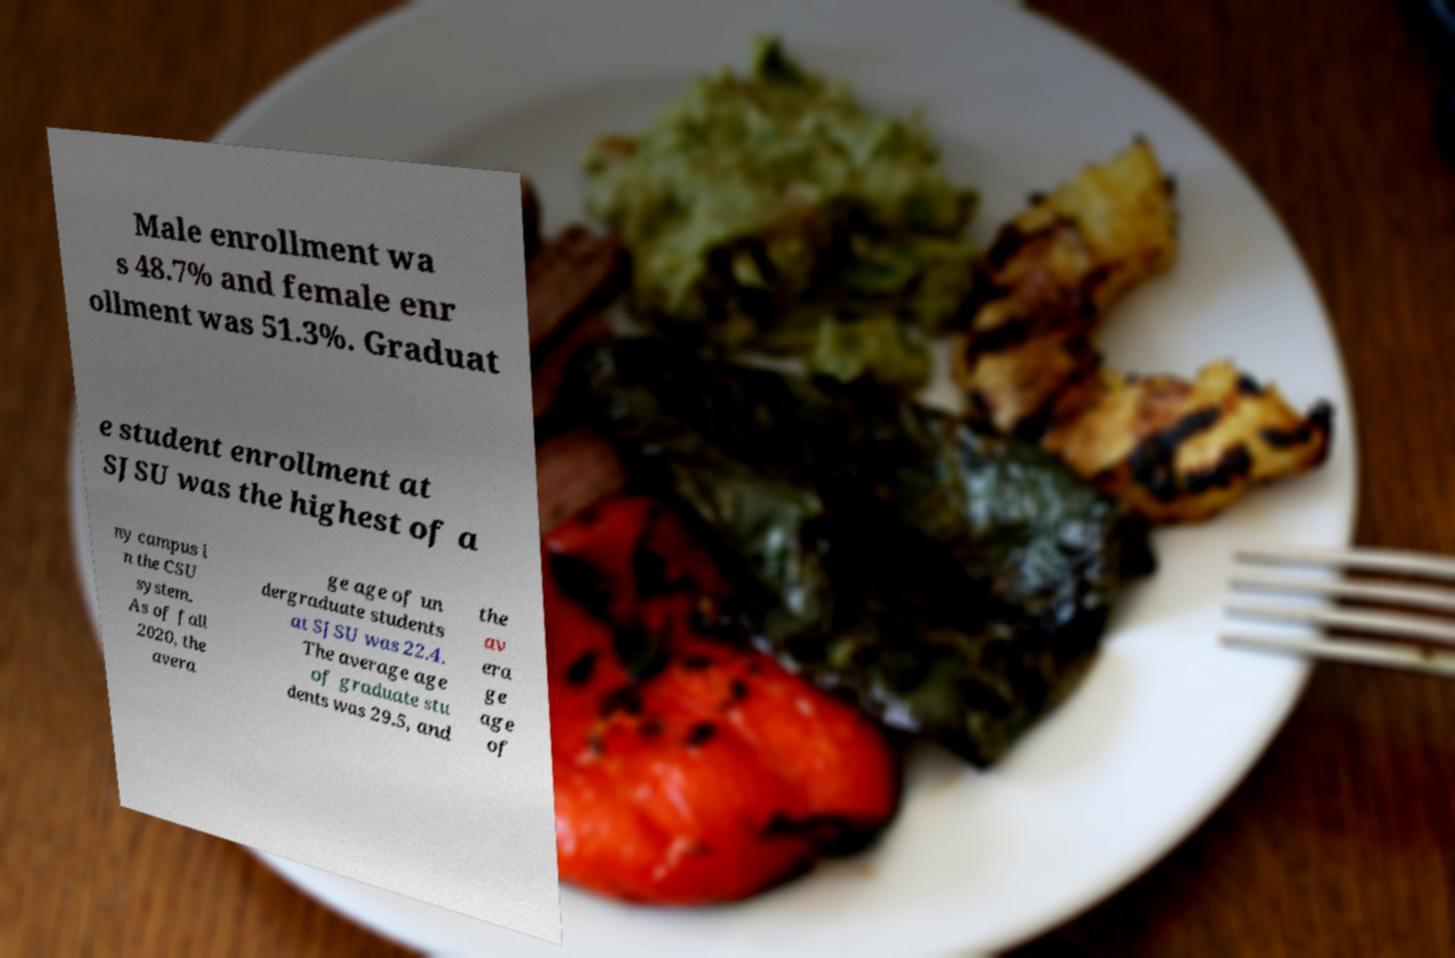Could you assist in decoding the text presented in this image and type it out clearly? Male enrollment wa s 48.7% and female enr ollment was 51.3%. Graduat e student enrollment at SJSU was the highest of a ny campus i n the CSU system. As of fall 2020, the avera ge age of un dergraduate students at SJSU was 22.4. The average age of graduate stu dents was 29.5, and the av era ge age of 